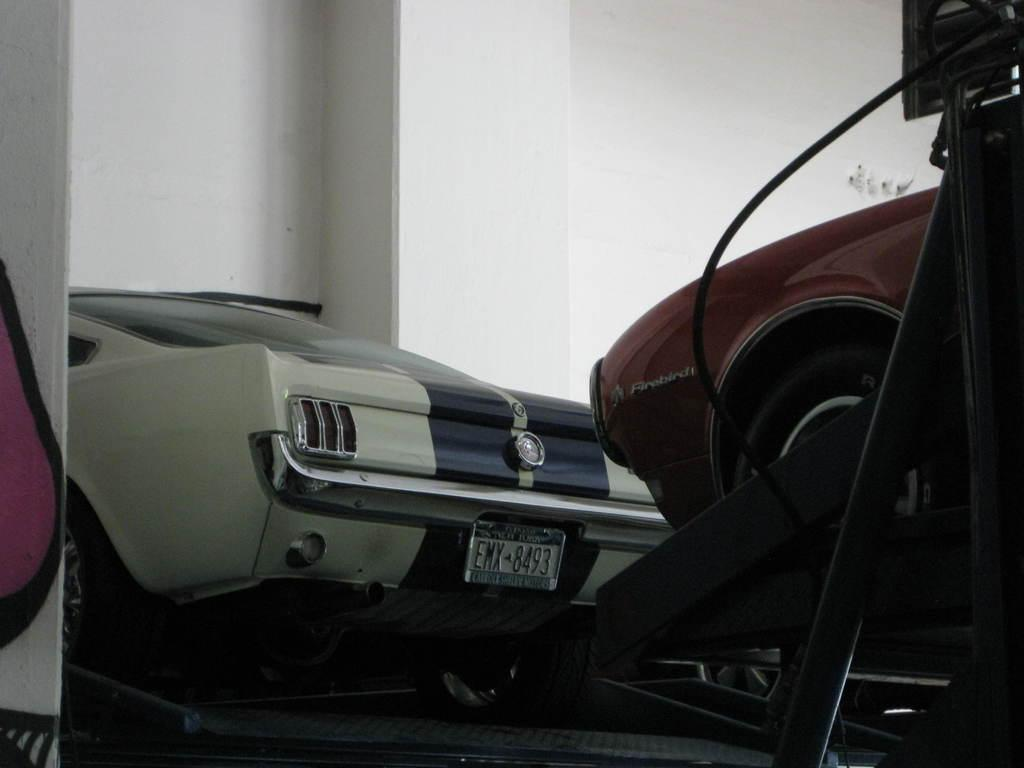What types of objects are present in the image? There are vehicles in the image. Can you describe the background of the image? There is a wall behind the vehicles in the image. How many beds can be seen in the image? There are no beds present in the image. 